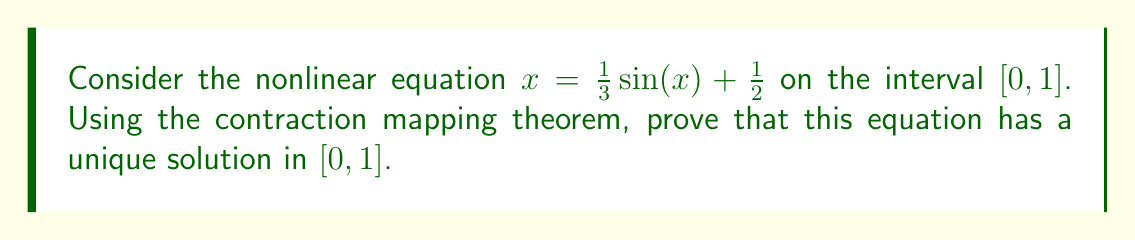Provide a solution to this math problem. Let's approach this step-by-step:

1) Define the function $f(x) = \frac{1}{3} \sin(x) + \frac{1}{2}$. We need to show that $f$ is a contraction mapping on $[0, 1]$.

2) For $f$ to be a contraction mapping, we need to show that:
   a) $f$ maps $[0, 1]$ into itself
   b) There exists a constant $k < 1$ such that $|f(x) - f(y)| \leq k|x - y|$ for all $x, y \in [0, 1]$

3) To show (a):
   For $x \in [0, 1]$, 
   $0 \leq \frac{1}{3} \sin(x) + \frac{1}{2} \leq \frac{1}{3} + \frac{1}{2} = \frac{5}{6} < 1$
   So $f$ maps $[0, 1]$ into itself.

4) To show (b):
   $|f'(x)| = |\frac{1}{3} \cos(x)| \leq \frac{1}{3} < 1$ for all $x \in [0, 1]$
   By the Mean Value Theorem, for any $x, y \in [0, 1]$, there exists $c$ between $x$ and $y$ such that:
   $|f(x) - f(y)| = |f'(c)||x - y| \leq \frac{1}{3}|x - y|$

5) Thus, $f$ is a contraction mapping with $k = \frac{1}{3}$.

6) By the Contraction Mapping Theorem, $f$ has a unique fixed point in $[0, 1]$, which is the unique solution to the equation $x = f(x)$.

Therefore, the equation $x = \frac{1}{3} \sin(x) + \frac{1}{2}$ has a unique solution in $[0, 1]$.
Answer: Unique solution exists in $[0, 1]$ 